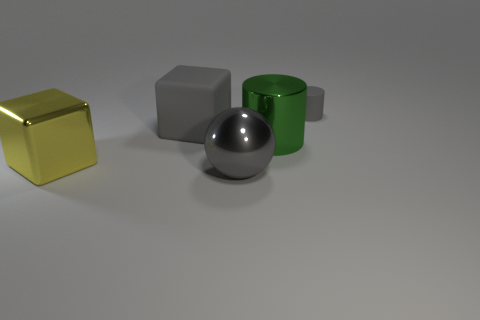What might be the purpose of arranging these objects in this way? This arrangement could be designed to showcase the contrast in textures and colors between the objects. It might be an artistic composition or a setup for a visual experiment to study material properties and how they interact with light. 